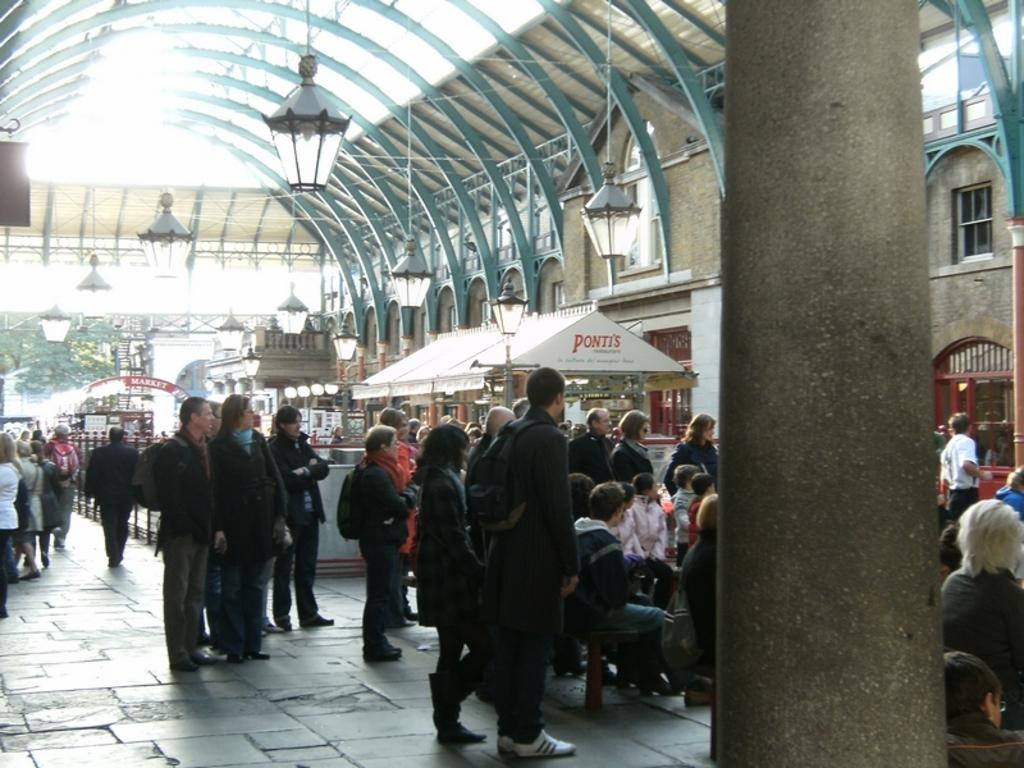<image>
Offer a succinct explanation of the picture presented. A busy station with a Ponti's marquee tent in the middle. 